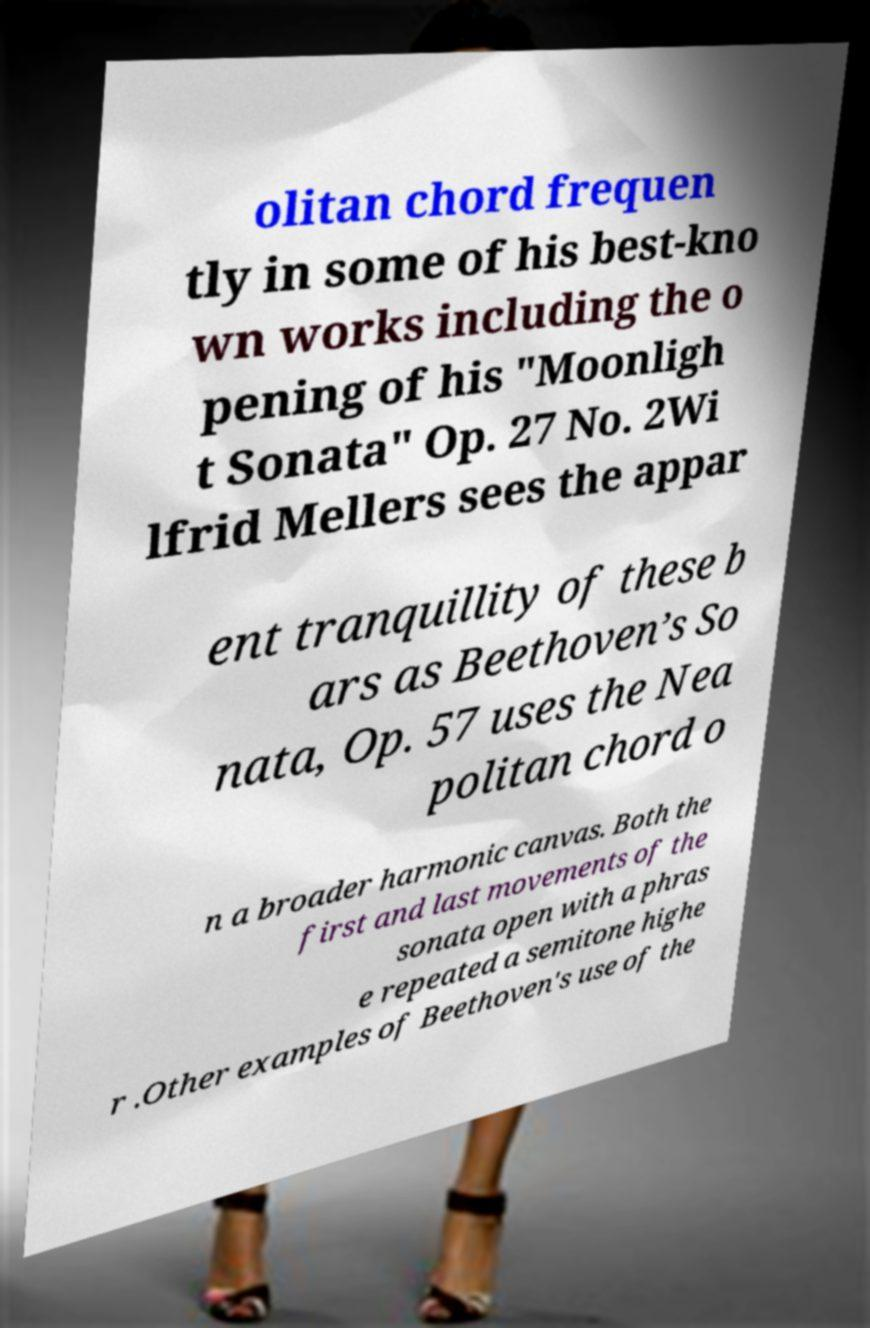I need the written content from this picture converted into text. Can you do that? olitan chord frequen tly in some of his best-kno wn works including the o pening of his "Moonligh t Sonata" Op. 27 No. 2Wi lfrid Mellers sees the appar ent tranquillity of these b ars as Beethoven’s So nata, Op. 57 uses the Nea politan chord o n a broader harmonic canvas. Both the first and last movements of the sonata open with a phras e repeated a semitone highe r .Other examples of Beethoven's use of the 